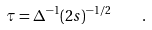Convert formula to latex. <formula><loc_0><loc_0><loc_500><loc_500>\tau = \Delta ^ { - 1 } ( 2 s ) ^ { - 1 / 2 } \quad .</formula> 